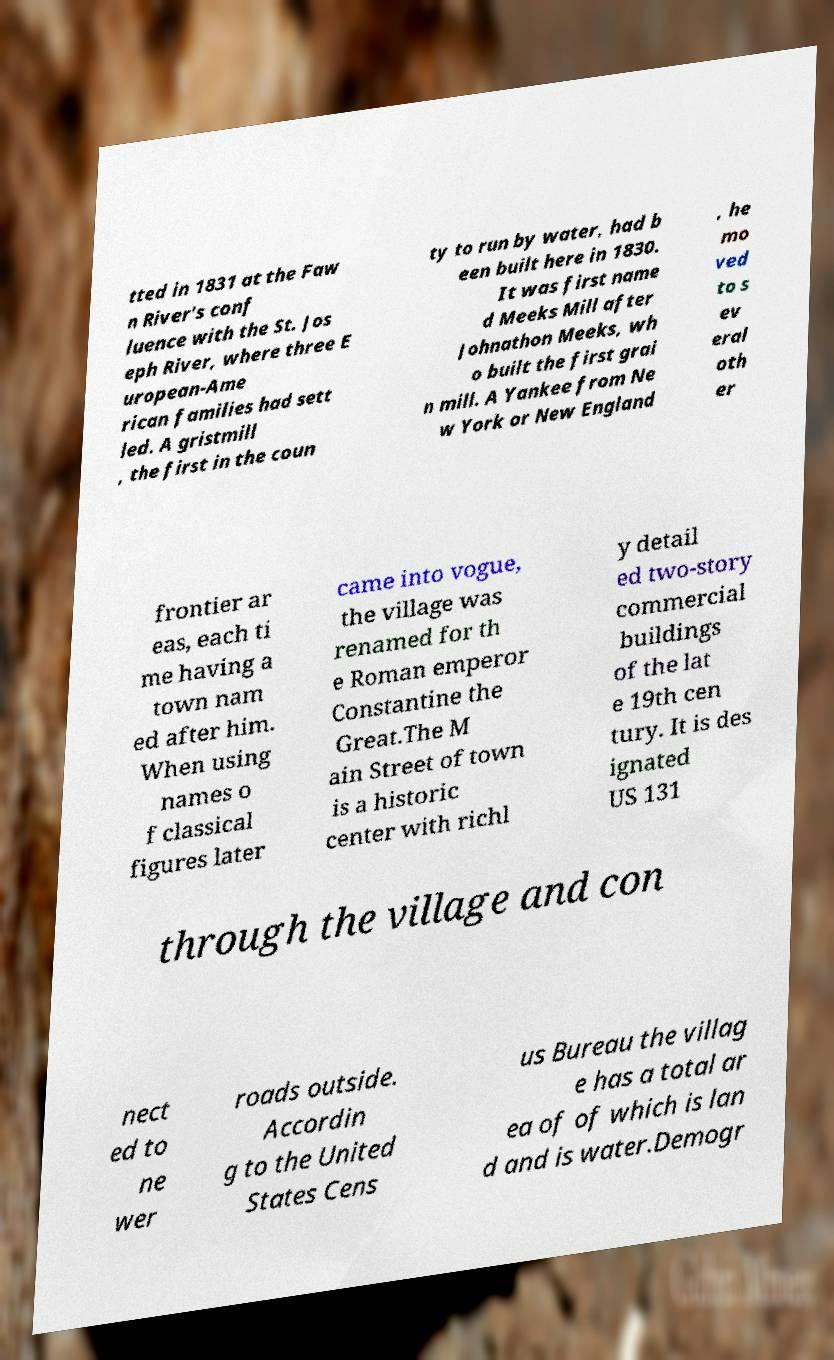Please read and relay the text visible in this image. What does it say? tted in 1831 at the Faw n River's conf luence with the St. Jos eph River, where three E uropean-Ame rican families had sett led. A gristmill , the first in the coun ty to run by water, had b een built here in 1830. It was first name d Meeks Mill after Johnathon Meeks, wh o built the first grai n mill. A Yankee from Ne w York or New England , he mo ved to s ev eral oth er frontier ar eas, each ti me having a town nam ed after him. When using names o f classical figures later came into vogue, the village was renamed for th e Roman emperor Constantine the Great.The M ain Street of town is a historic center with richl y detail ed two-story commercial buildings of the lat e 19th cen tury. It is des ignated US 131 through the village and con nect ed to ne wer roads outside. Accordin g to the United States Cens us Bureau the villag e has a total ar ea of of which is lan d and is water.Demogr 